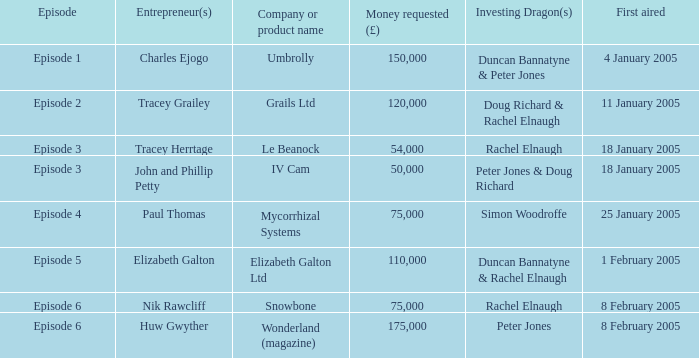Who were the Investing Dragons in the episode that first aired on 18 January 2005 with the entrepreneur Tracey Herrtage? Rachel Elnaugh. Could you parse the entire table as a dict? {'header': ['Episode', 'Entrepreneur(s)', 'Company or product name', 'Money requested (£)', 'Investing Dragon(s)', 'First aired'], 'rows': [['Episode 1', 'Charles Ejogo', 'Umbrolly', '150,000', 'Duncan Bannatyne & Peter Jones', '4 January 2005'], ['Episode 2', 'Tracey Grailey', 'Grails Ltd', '120,000', 'Doug Richard & Rachel Elnaugh', '11 January 2005'], ['Episode 3', 'Tracey Herrtage', 'Le Beanock', '54,000', 'Rachel Elnaugh', '18 January 2005'], ['Episode 3', 'John and Phillip Petty', 'IV Cam', '50,000', 'Peter Jones & Doug Richard', '18 January 2005'], ['Episode 4', 'Paul Thomas', 'Mycorrhizal Systems', '75,000', 'Simon Woodroffe', '25 January 2005'], ['Episode 5', 'Elizabeth Galton', 'Elizabeth Galton Ltd', '110,000', 'Duncan Bannatyne & Rachel Elnaugh', '1 February 2005'], ['Episode 6', 'Nik Rawcliff', 'Snowbone', '75,000', 'Rachel Elnaugh', '8 February 2005'], ['Episode 6', 'Huw Gwyther', 'Wonderland (magazine)', '175,000', 'Peter Jones', '8 February 2005']]} 